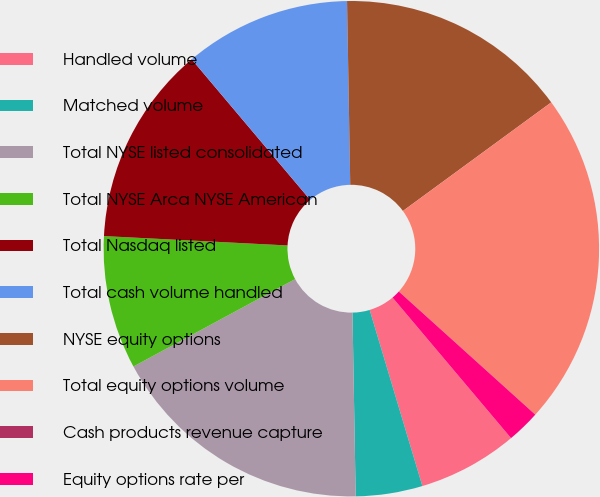Convert chart to OTSL. <chart><loc_0><loc_0><loc_500><loc_500><pie_chart><fcel>Handled volume<fcel>Matched volume<fcel>Total NYSE listed consolidated<fcel>Total NYSE Arca NYSE American<fcel>Total Nasdaq listed<fcel>Total cash volume handled<fcel>NYSE equity options<fcel>Total equity options volume<fcel>Cash products revenue capture<fcel>Equity options rate per<nl><fcel>6.52%<fcel>4.35%<fcel>17.39%<fcel>8.7%<fcel>13.04%<fcel>10.87%<fcel>15.22%<fcel>21.74%<fcel>0.0%<fcel>2.17%<nl></chart> 